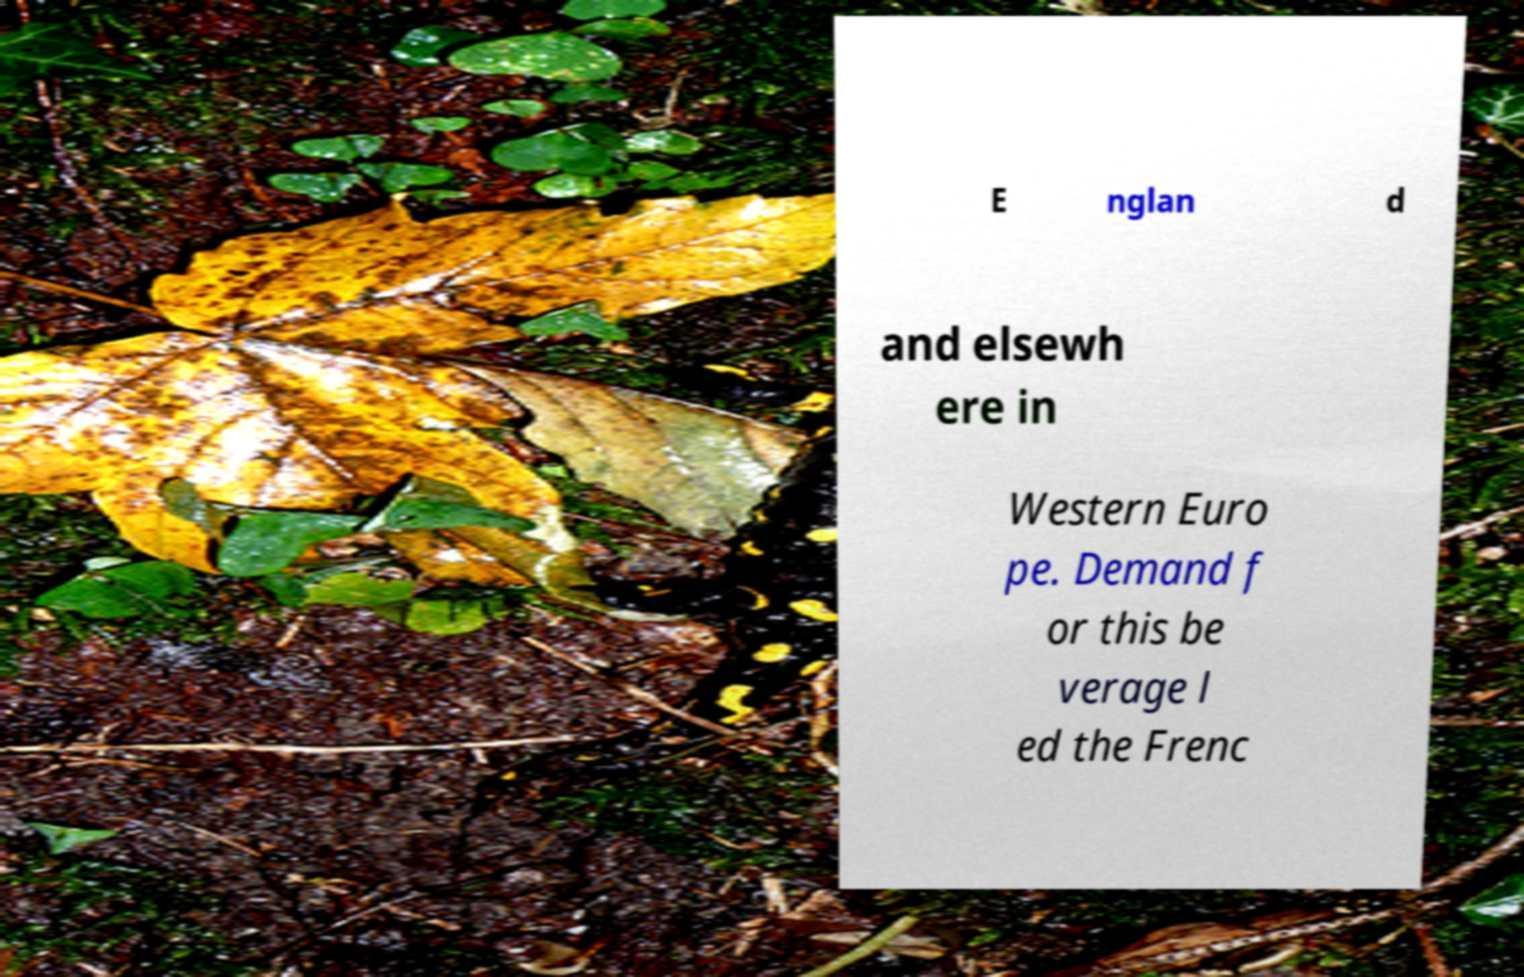Can you read and provide the text displayed in the image?This photo seems to have some interesting text. Can you extract and type it out for me? E nglan d and elsewh ere in Western Euro pe. Demand f or this be verage l ed the Frenc 